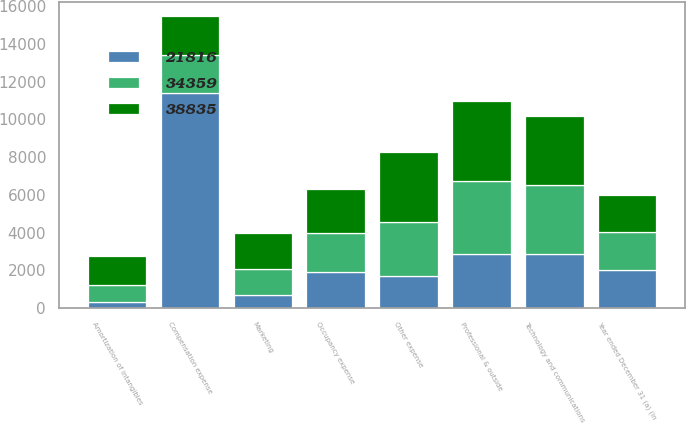Convert chart. <chart><loc_0><loc_0><loc_500><loc_500><stacked_bar_chart><ecel><fcel>Year ended December 31 (a) (in<fcel>Compensation expense<fcel>Occupancy expense<fcel>Technology and communications<fcel>Professional & outside<fcel>Marketing<fcel>Other expense<fcel>Amortization of intangibles<nl><fcel>38835<fcel>2005<fcel>2044.5<fcel>2299<fcel>3624<fcel>4224<fcel>1917<fcel>3705<fcel>1525<nl><fcel>34359<fcel>2004<fcel>2044.5<fcel>2084<fcel>3702<fcel>3862<fcel>1335<fcel>2859<fcel>946<nl><fcel>21816<fcel>2003<fcel>11387<fcel>1912<fcel>2844<fcel>2875<fcel>710<fcel>1694<fcel>294<nl></chart> 